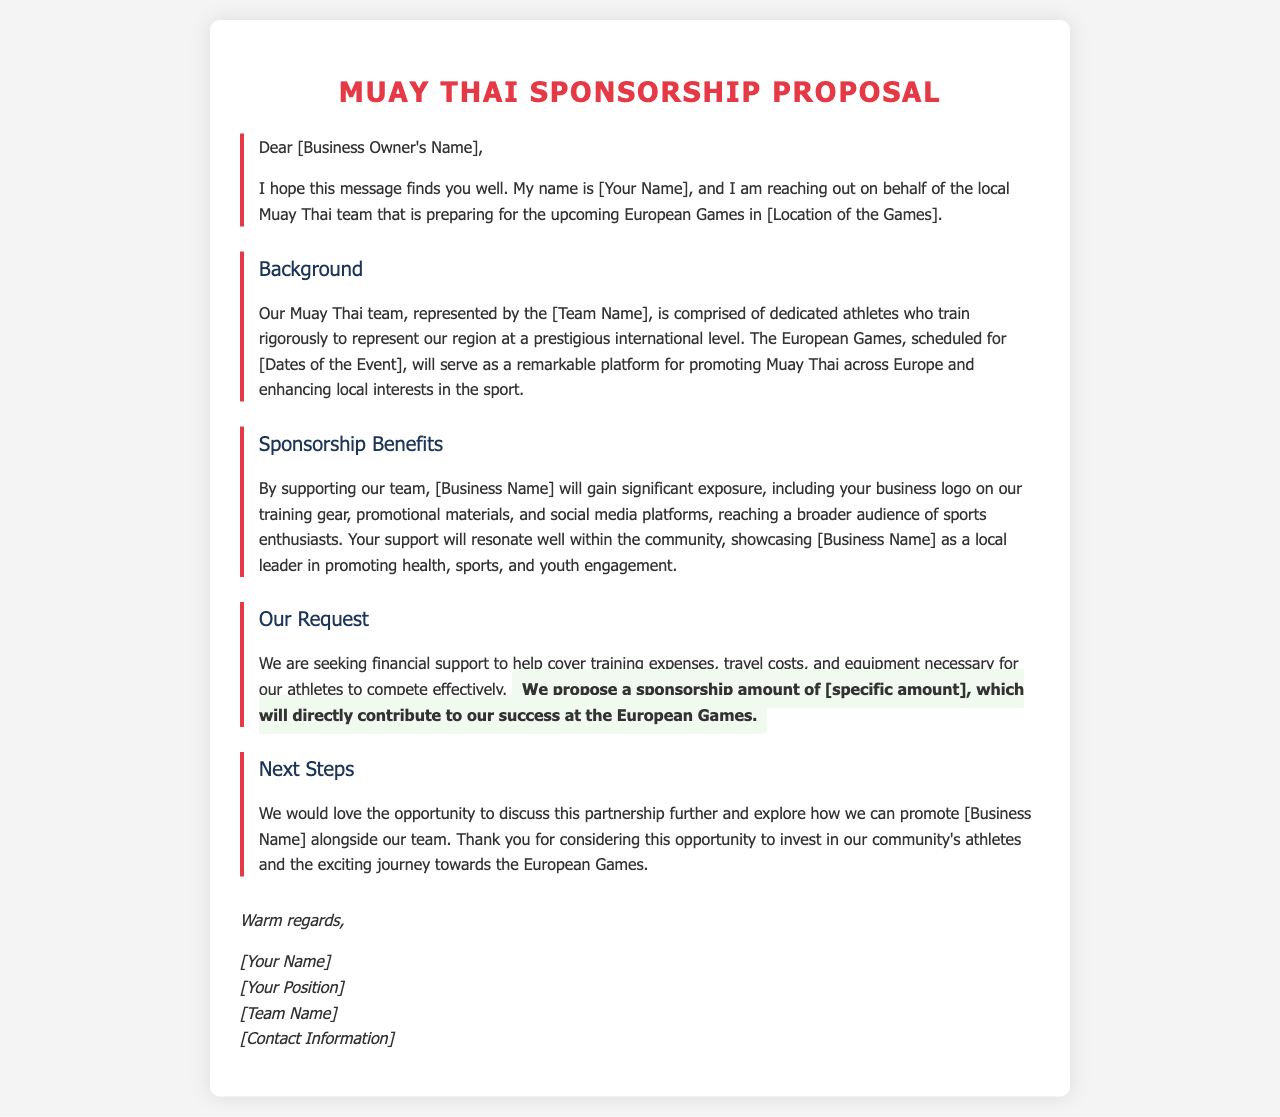what is the name of the local Muay Thai team? The letter mentions the team as [Team Name], indicating a placeholder for the actual team name.
Answer: [Team Name] what is requested from the business? The document states that financial support is needed, which is highlighted as crucial for covering various costs.
Answer: financial support where will the European Games be held? The document mentions they are preparing for the event in [Location of the Games], which is a placeholder for the actual location.
Answer: [Location of the Games] what is the proposed sponsorship amount? The letter suggests a specific sponsorship amount, but it is shown as a placeholder.
Answer: [specific amount] what is one benefit of sponsoring the team? One highlighted benefit is gaining significant exposure through various promotional materials where the business logo will appear.
Answer: significant exposure who is the sender of the letter? The signature section of the letter includes placeholders for the sender's name and position.
Answer: [Your Name] what are the dates of the event? The letter mentions the event is scheduled for [Dates of the Event], using a placeholder that requires specific details.
Answer: [Dates of the Event] how will the sponsorship benefit community engagement? The document articulates that supporting the team showcases the business as a local leader in promoting health, sports, and youth engagement.
Answer: local leader in promoting health, sports, and youth engagement what is the tone of the closing remarks in the letter? The letter concludes with a warm and inviting tone, indicating a positive approach to building a partnership.
Answer: warm regards 